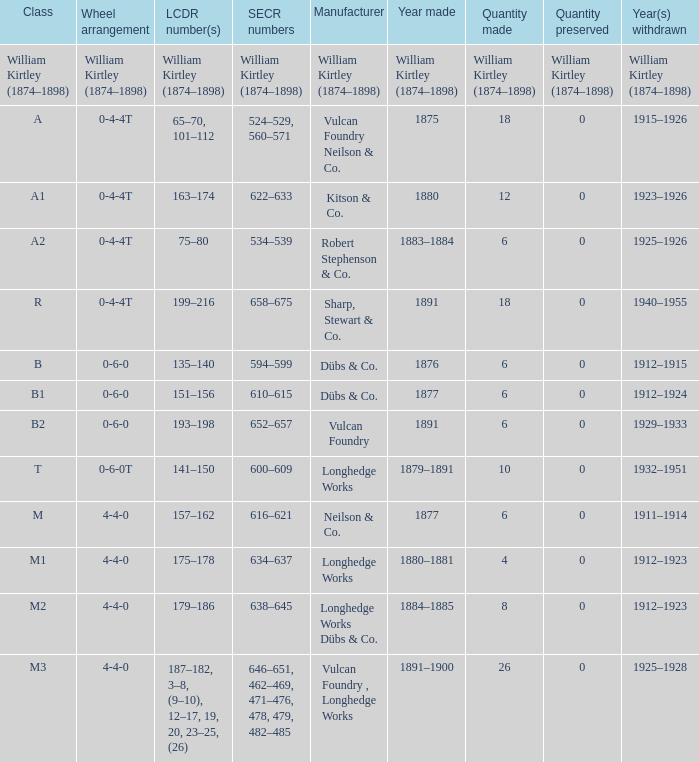Which class was made in 1880? A1. 